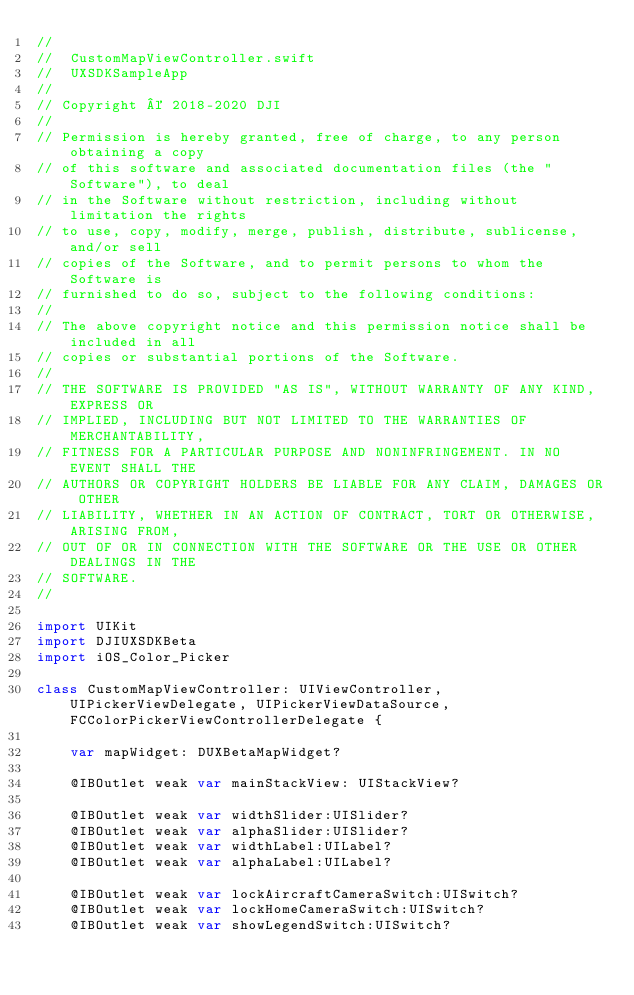<code> <loc_0><loc_0><loc_500><loc_500><_Swift_>//
//  CustomMapViewController.swift
//  UXSDKSampleApp
//
// Copyright © 2018-2020 DJI
//
// Permission is hereby granted, free of charge, to any person obtaining a copy
// of this software and associated documentation files (the "Software"), to deal
// in the Software without restriction, including without limitation the rights
// to use, copy, modify, merge, publish, distribute, sublicense, and/or sell
// copies of the Software, and to permit persons to whom the Software is
// furnished to do so, subject to the following conditions:
//
// The above copyright notice and this permission notice shall be included in all
// copies or substantial portions of the Software.
//
// THE SOFTWARE IS PROVIDED "AS IS", WITHOUT WARRANTY OF ANY KIND, EXPRESS OR
// IMPLIED, INCLUDING BUT NOT LIMITED TO THE WARRANTIES OF MERCHANTABILITY,
// FITNESS FOR A PARTICULAR PURPOSE AND NONINFRINGEMENT. IN NO EVENT SHALL THE
// AUTHORS OR COPYRIGHT HOLDERS BE LIABLE FOR ANY CLAIM, DAMAGES OR OTHER
// LIABILITY, WHETHER IN AN ACTION OF CONTRACT, TORT OR OTHERWISE, ARISING FROM,
// OUT OF OR IN CONNECTION WITH THE SOFTWARE OR THE USE OR OTHER DEALINGS IN THE
// SOFTWARE.
//

import UIKit
import DJIUXSDKBeta
import iOS_Color_Picker

class CustomMapViewController: UIViewController, UIPickerViewDelegate, UIPickerViewDataSource, FCColorPickerViewControllerDelegate {
    
    var mapWidget: DUXBetaMapWidget?
    
    @IBOutlet weak var mainStackView: UIStackView?
    
    @IBOutlet weak var widthSlider:UISlider?
    @IBOutlet weak var alphaSlider:UISlider?
    @IBOutlet weak var widthLabel:UILabel?
    @IBOutlet weak var alphaLabel:UILabel?
    
    @IBOutlet weak var lockAircraftCameraSwitch:UISwitch?
    @IBOutlet weak var lockHomeCameraSwitch:UISwitch?
    @IBOutlet weak var showLegendSwitch:UISwitch?
    </code> 